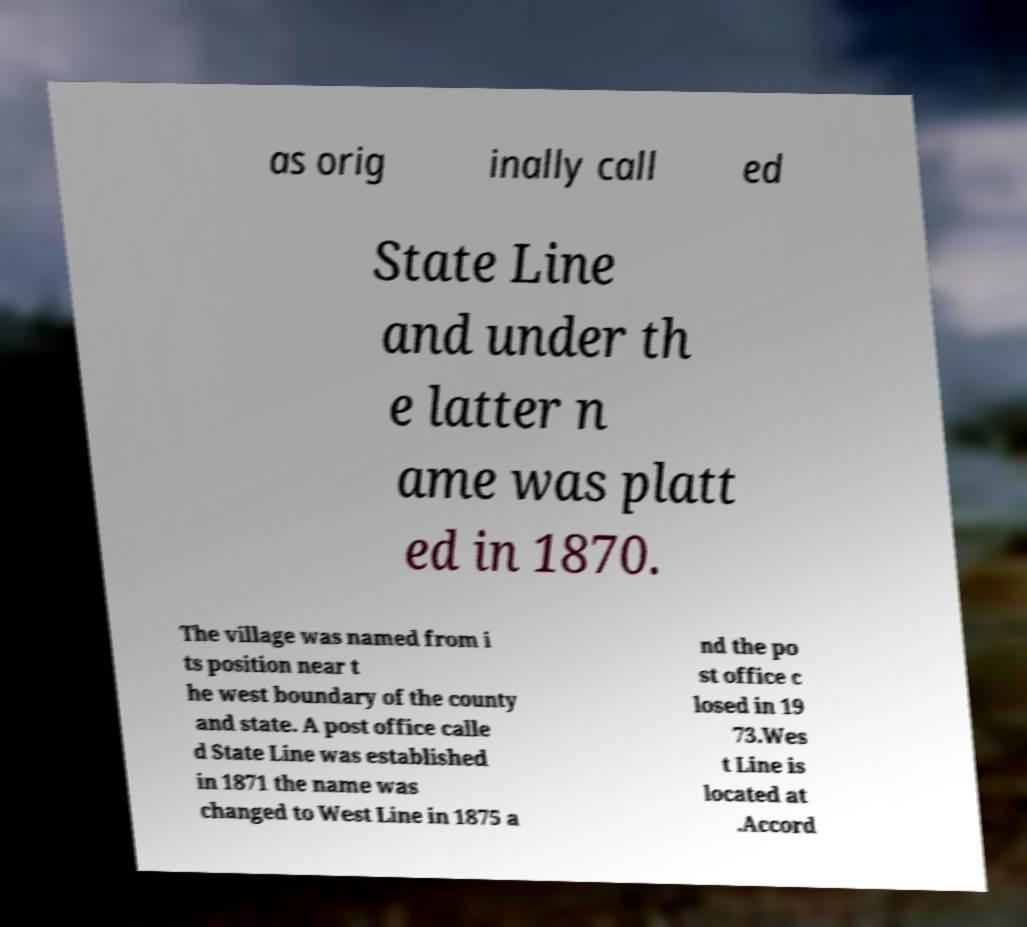What messages or text are displayed in this image? I need them in a readable, typed format. as orig inally call ed State Line and under th e latter n ame was platt ed in 1870. The village was named from i ts position near t he west boundary of the county and state. A post office calle d State Line was established in 1871 the name was changed to West Line in 1875 a nd the po st office c losed in 19 73.Wes t Line is located at .Accord 